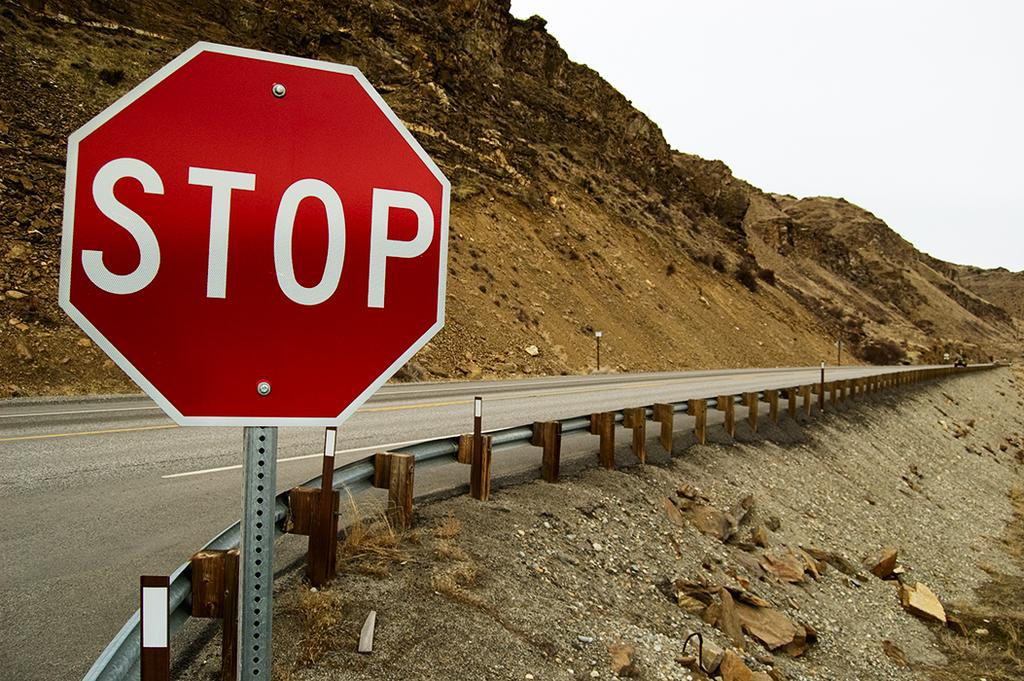<image>
Create a compact narrative representing the image presented. A stop sign is on the side of an empty road behind railing. 